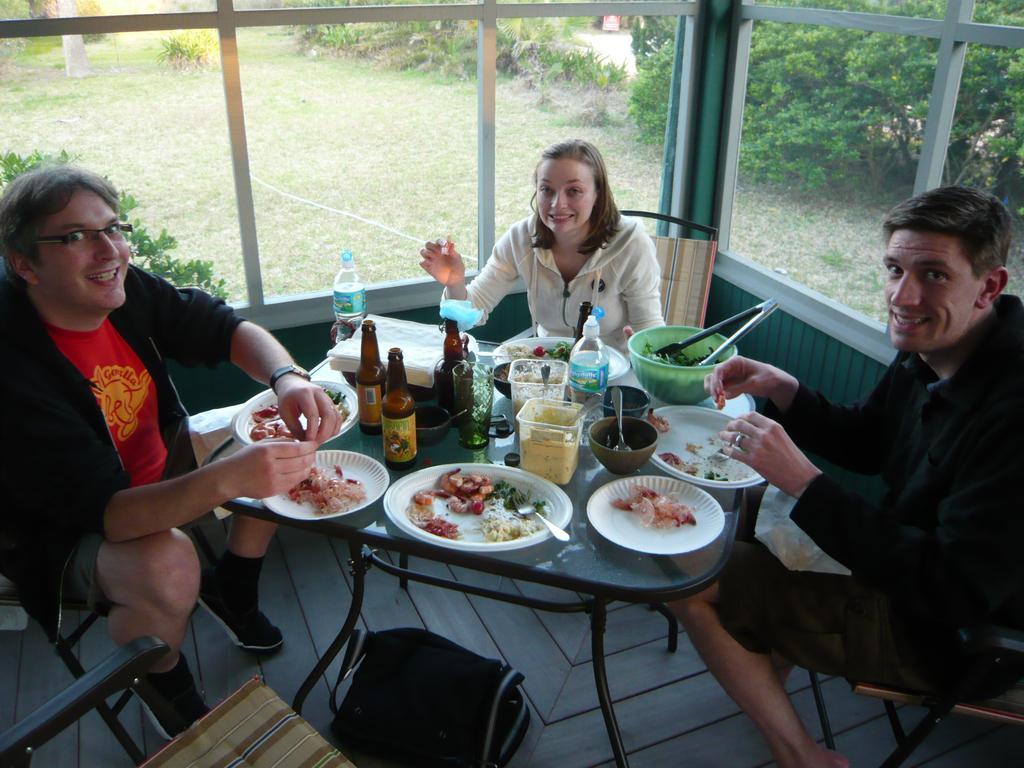Describe this image in one or two sentences. There are 3 people sitting on a chairs. There is a table. There is a plate,bowl,spoon and tissue on a table. We can see in background curtain,window, 